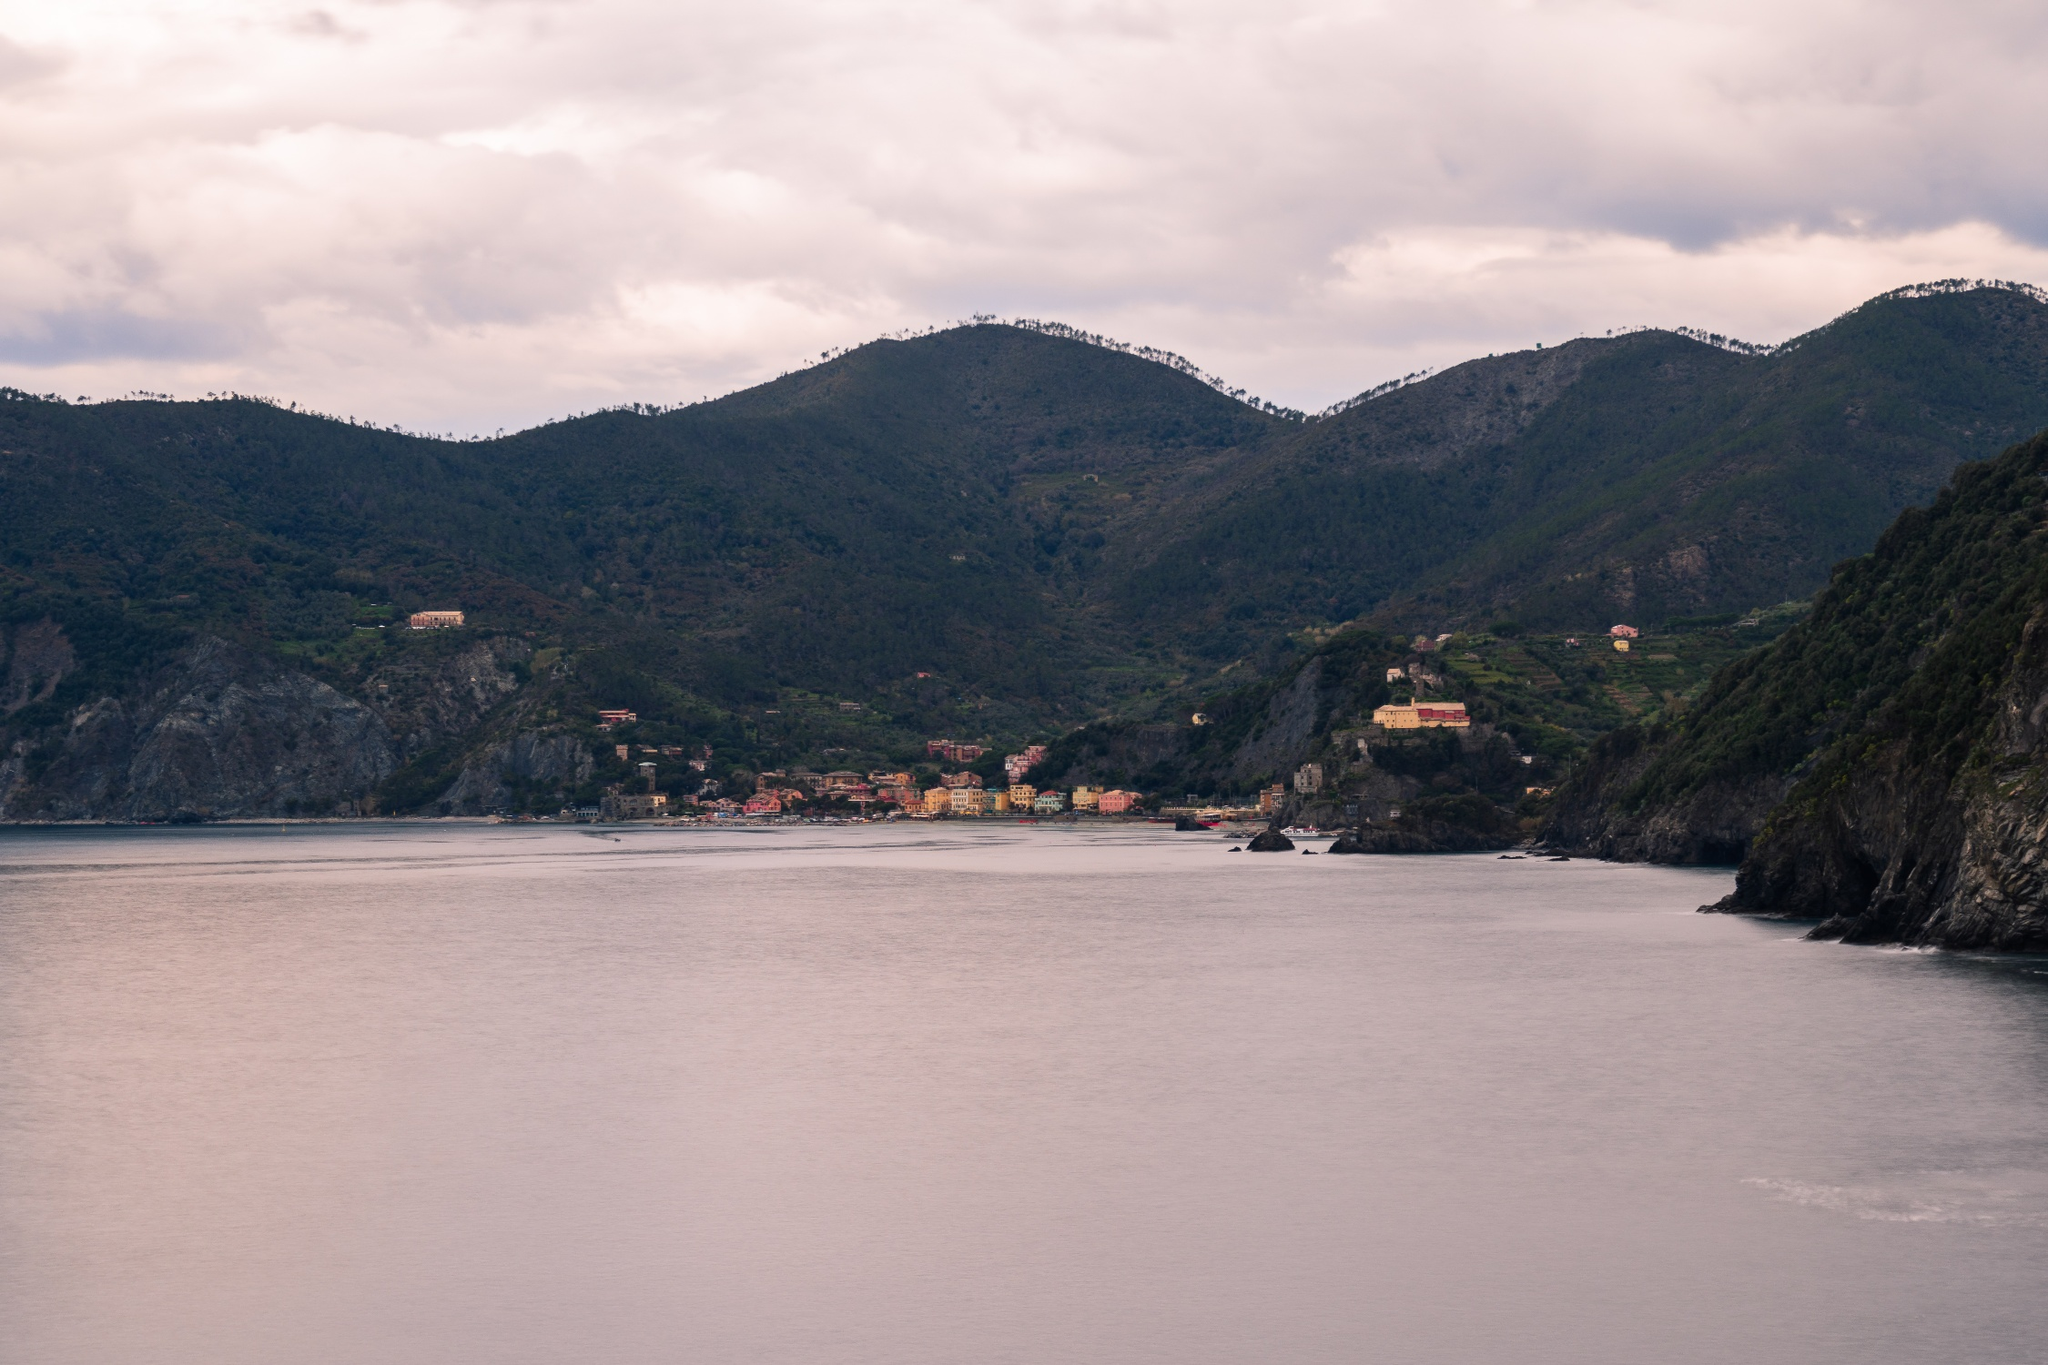If this town had a rich history, what kind of stories might it tell? This town, perched gracefully on the coastal cliffs, likely has a history as rich and colorful as its buildings. Stories of ancient maritime adventures would be abundant, with tales of fishermen braving the treacherous sea, and traders arriving with exotic goods from distant lands. The town could have been a refuge for sailors during storms and a hub of commerce in calmer times. Legends of hidden treasures, lost to the depths of the ocean, might be whispered among the locals. The architecture would tell tales of different eras, from ancient stone structures to more modern buildings. Historical narratives could include periods of prosperity, times of struggle against natural disasters, and the communal effort to rebuild and thrive. Festivities and traditions passed down through generations would reflect a deep cultural heritage, intertwined with the natural beauty of the town's surroundings. What if this town was the setting for a magical story? Can you create an outline for a whimsical tale? Once upon a time in the enchanted coastal town of Vistamar, where colorful buildings graced the cliffs and the sea shimmered with an otherworldly glow, lived a young girl named Elara. Elara discovered an ancient, seaweed-covered book washed ashore, filled with tales of magic and mythical creatures. Among the tales, one spoke of a hidden underwater kingdom accessible only during the full moon. Armed with curiosity and courage, Elara waited for the full moon and set out on a boat equipped with a magical amulet, passed down through her family for generations. As she ventured into the sea, the amulet began to glow, guiding her towards a shimmering portal. Elara found herself in an underwater world teeming with bioluminescent sea creatures and towering coral castles. She befriended the merfolk and helped them thwart a looming threat from dark sea witches. After restoring peace, she returned to Vistamar, her heart filled with wonder, and her tales became the stuff of legends, passed down in the town's folklore for centuries. 